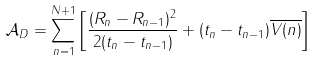Convert formula to latex. <formula><loc_0><loc_0><loc_500><loc_500>\mathcal { A } _ { D } = \sum _ { n = 1 } ^ { N + 1 } \left [ \frac { ( R _ { n } - R _ { n - 1 } ) ^ { 2 } } { 2 ( t _ { n } - t _ { n - 1 } ) } + ( t _ { n } - t _ { n - 1 } ) \overline { V ( n ) } \right ]</formula> 